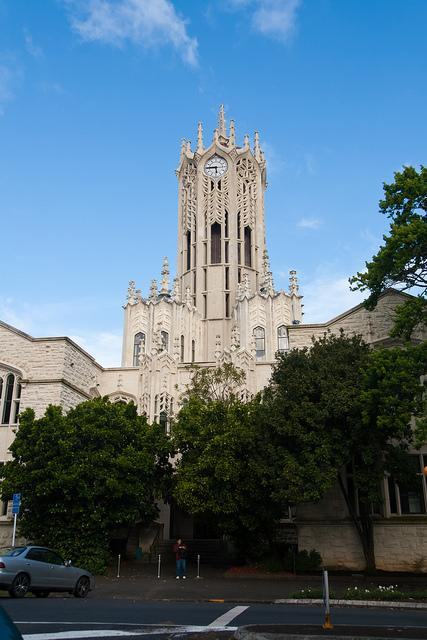What country is this building in? spain 